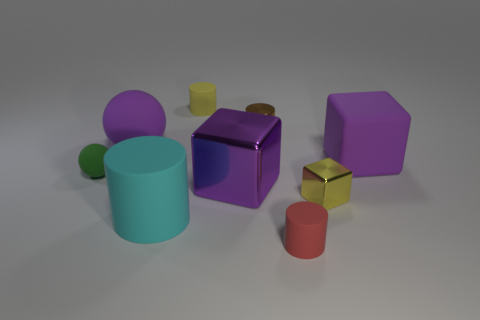How many objects are small brown cylinders or cyan matte objects that are in front of the matte block?
Offer a very short reply. 2. There is another purple thing that is the same shape as the large purple shiny object; what is it made of?
Offer a terse response. Rubber. Is there any other thing that has the same material as the tiny red cylinder?
Give a very brief answer. Yes. There is a object that is behind the large metallic thing and on the right side of the small metal cylinder; what is its material?
Your response must be concise. Rubber. What number of other things have the same shape as the red object?
Offer a terse response. 3. There is a rubber object to the right of the small yellow thing that is to the right of the red rubber cylinder; what is its color?
Make the answer very short. Purple. Are there the same number of brown cylinders in front of the small yellow block and rubber things?
Provide a succinct answer. No. Is there a green sphere of the same size as the red object?
Your response must be concise. Yes. There is a brown cylinder; is its size the same as the purple matte thing that is to the left of the big cyan object?
Offer a very short reply. No. Are there an equal number of large purple shiny blocks in front of the small yellow shiny object and big rubber cubes in front of the cyan object?
Your answer should be very brief. Yes. 